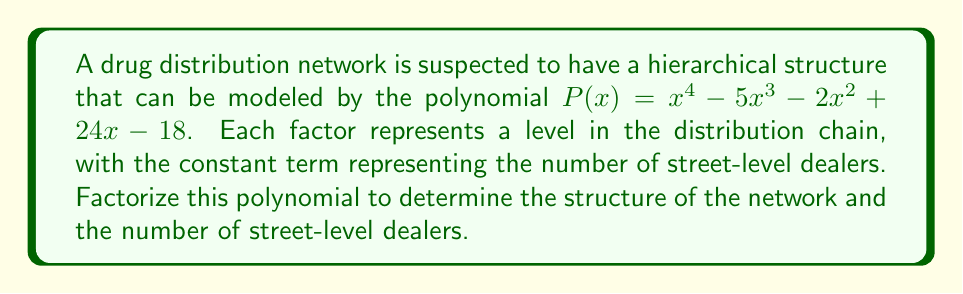Provide a solution to this math problem. To factorize the polynomial $P(x) = x^4 - 5x^3 - 2x^2 + 24x - 18$, we'll use the following steps:

1) First, let's check for rational roots using the rational root theorem. The possible rational roots are the factors of the constant term (18): ±1, ±2, ±3, ±6, ±9, ±18.

2) Testing these values, we find that x = 1 and x = 3 are roots of the polynomial.

3) We can factor out (x - 1) and (x - 3):

   $P(x) = (x - 1)(x - 3)(ax^2 + bx + c)$

4) Expanding this and comparing coefficients with the original polynomial, we can determine that $a = 1$, $b = -1$, and $c = 6$.

5) So now we have:

   $P(x) = (x - 1)(x - 3)(x^2 - x + 6)$

6) The quadratic factor $x^2 - x + 6$ can't be factored further over the real numbers, as its discriminant is negative:

   $b^2 - 4ac = (-1)^2 - 4(1)(6) = 1 - 24 = -23 < 0$

Therefore, the complete factorization is:

$P(x) = (x - 1)(x - 3)(x^2 - x + 6)$

This factorization reveals the structure of the drug distribution network:
- There are four levels in total (degree of the polynomial is 4).
- Two levels are represented by linear factors (x - 1) and (x - 3).
- The other two levels are combined in a quadratic factor $(x^2 - x + 6)$, suggesting a more complex relationship.
- The constant term in the factored form is $(-1)(-3)(6) = 18$, confirming the number of street-level dealers.
Answer: The factored form of the polynomial is $P(x) = (x - 1)(x - 3)(x^2 - x + 6)$. This indicates a four-level distribution network with 18 street-level dealers. 